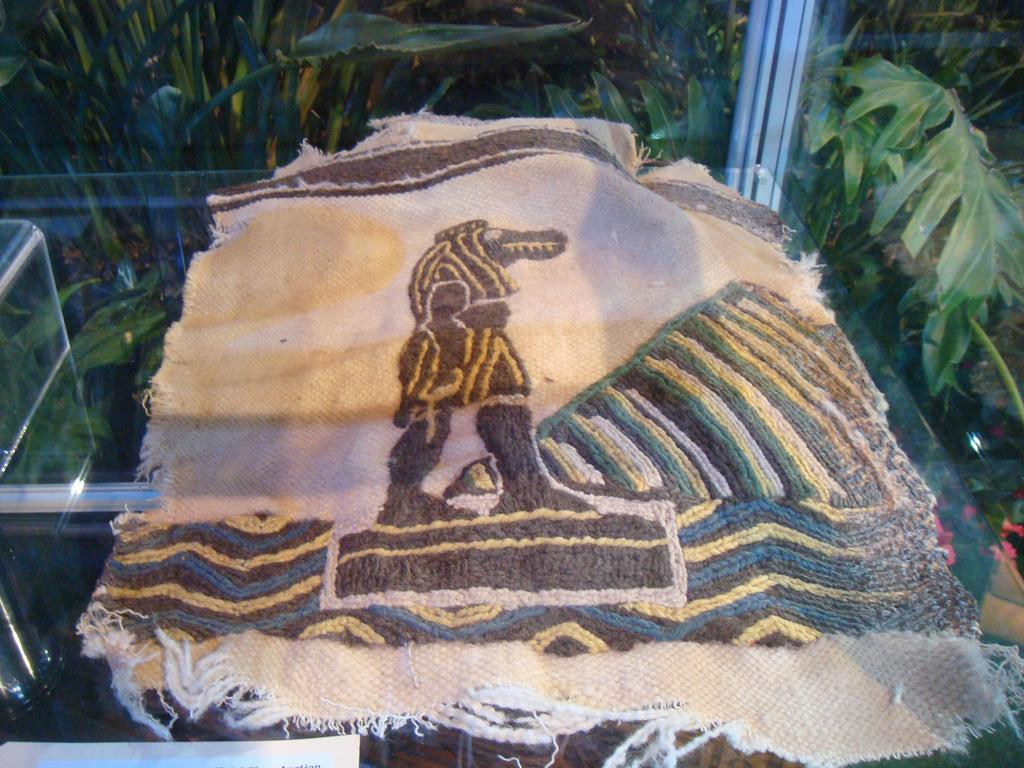What is placed on the table in the image? There is a cloth placed on a table in the image. What can be seen in the background of the image? There are trees visible in the background of the image. What type of voice can be heard coming from the cemetery in the image? There is no cemetery present in the image, so it's not possible to determine what, if any, voices might be heard. 